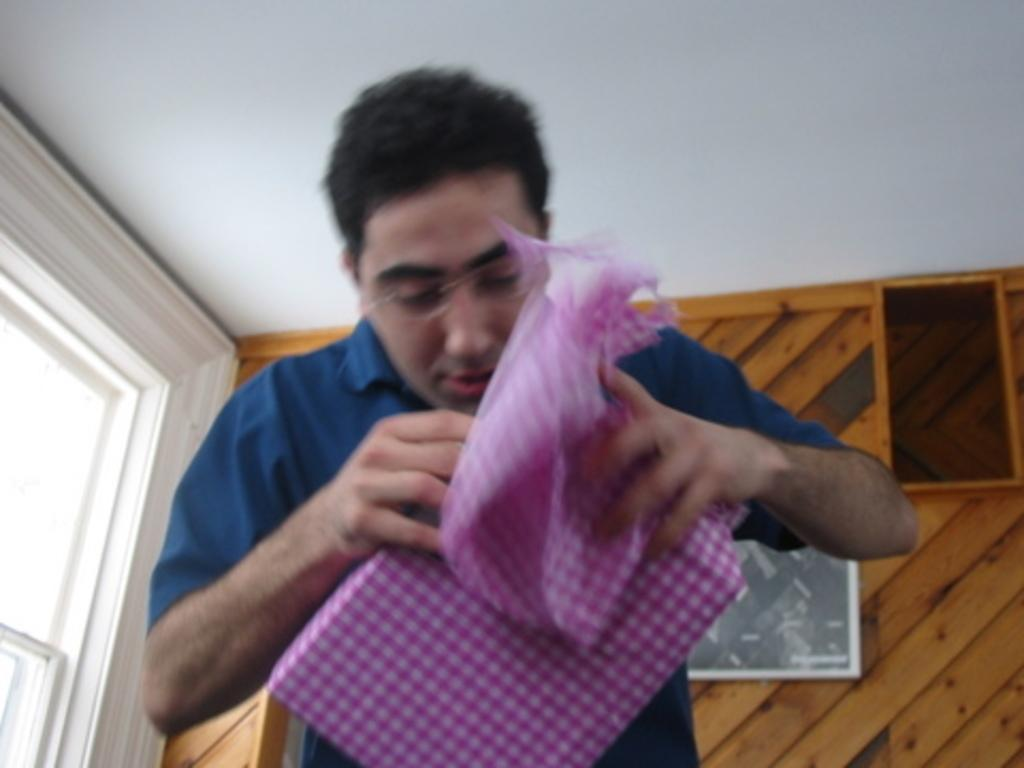Who or what can be seen in the image? There is a person in the image. What is the person doing in the image? The person is holding an object. What can be seen in the distance behind the person? There is a roof visible in the background of the image. Are there any other objects or structures visible in the background? Yes, there are objects present in the background of the image. What force is being applied to the object the person is holding in the image? There is no information about any force being applied to the object in the image. Can you hear the person in the image crying while holding the object? There is no audio information in the image, so it is impossible to determine if the person is crying or not. 